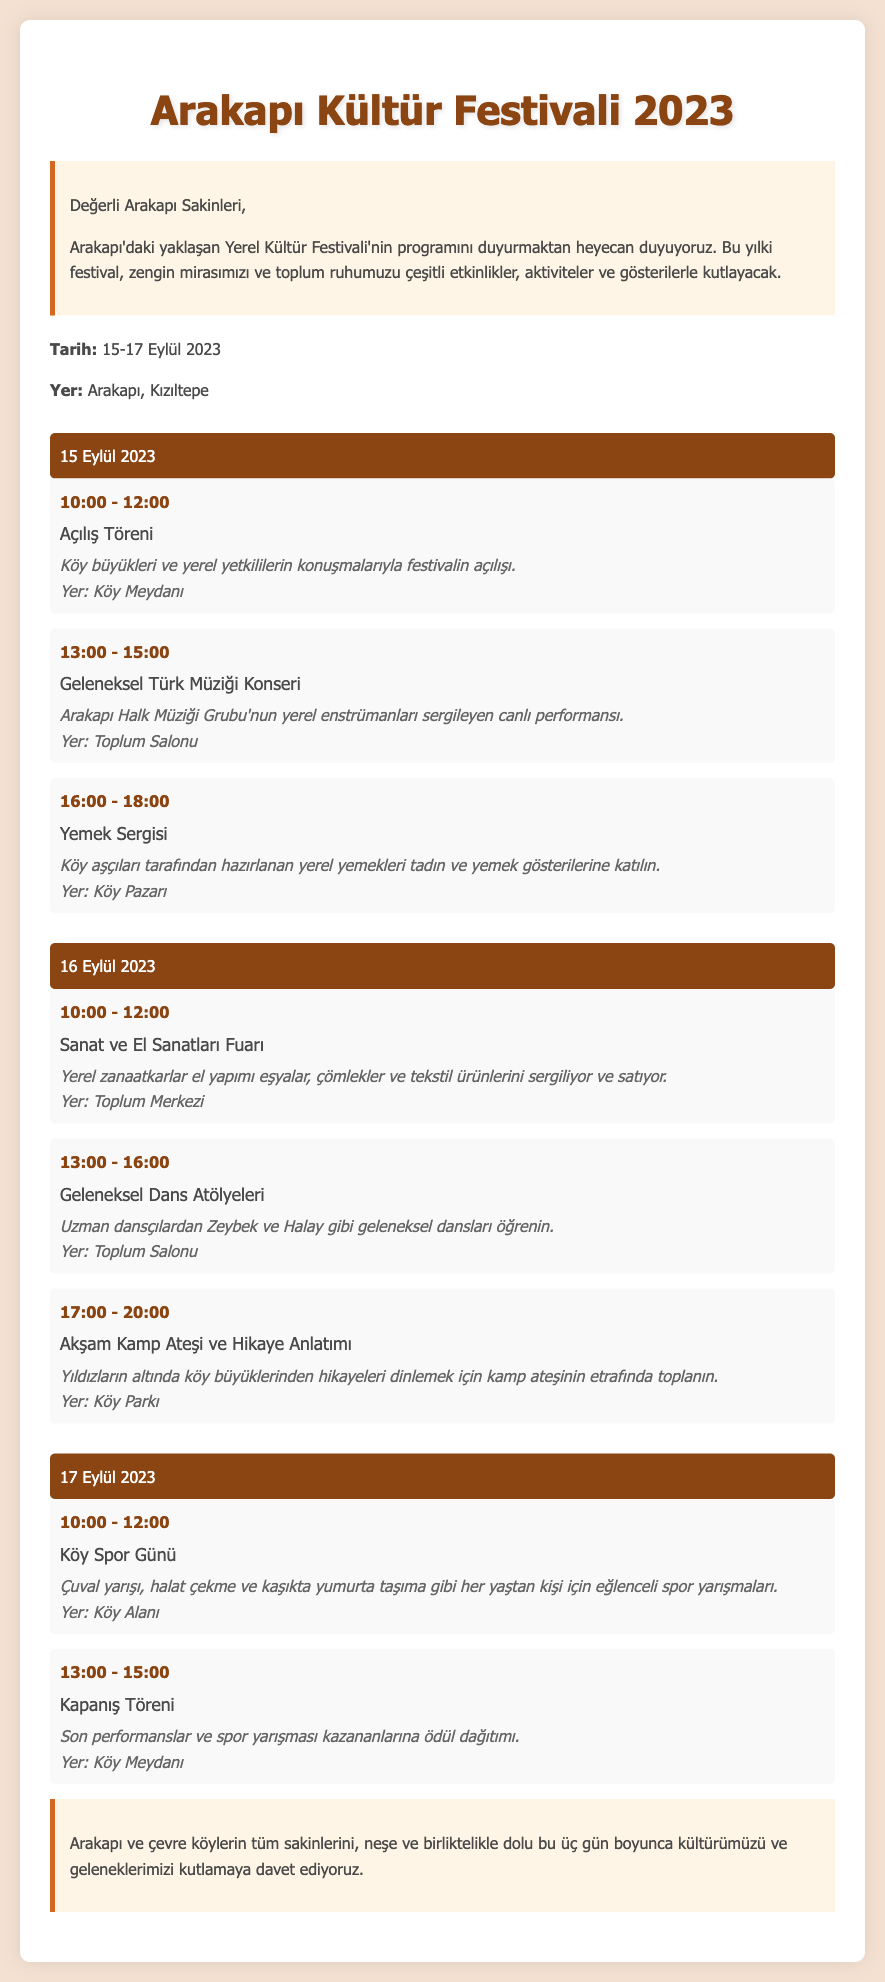what are the festival dates? The festival dates are explicitly stated in the document as 15-17 Eylül 2023.
Answer: 15-17 Eylül 2023 where is the festival taking place? The document clearly mentions that the festival is taking place in Arakapı, Kızıltepe.
Answer: Arakapı, Kızıltepe what is the first event on September 15th? The first event listed under September 15th is the Açılış Töreni.
Answer: Açılış Töreni how long does the traditional dance workshops last on September 16th? The duration of the traditional dance workshops is provided in the document as 3 hours, from 13:00 to 16:00.
Answer: 3 hours what type of activities are there on the final day of the festival? The document lists Köy Spor Günü and Kapanış Töreni as the activities scheduled for the final day.
Answer: Köy Spor Günü and Kapanış Töreni who will be performing during the traditional music concert? The concert will feature Arakapı Halk Müziği Grubu, as noted in the event details.
Answer: Arakapı Halk Müziği Grubu what is the location of the evening campfire storytelling on September 16th? The document specifies that this event will take place in the Köy Parkı.
Answer: Köy Parkı how many events are scheduled on September 17th? The document includes two events planned for September 17th: Köy Spor Günü and Kapanış Töreni.
Answer: 2 events what color is used for the date headers? The color used for the date headers is a specific shade mentioned in the document as #8b4513.
Answer: #8b4513 